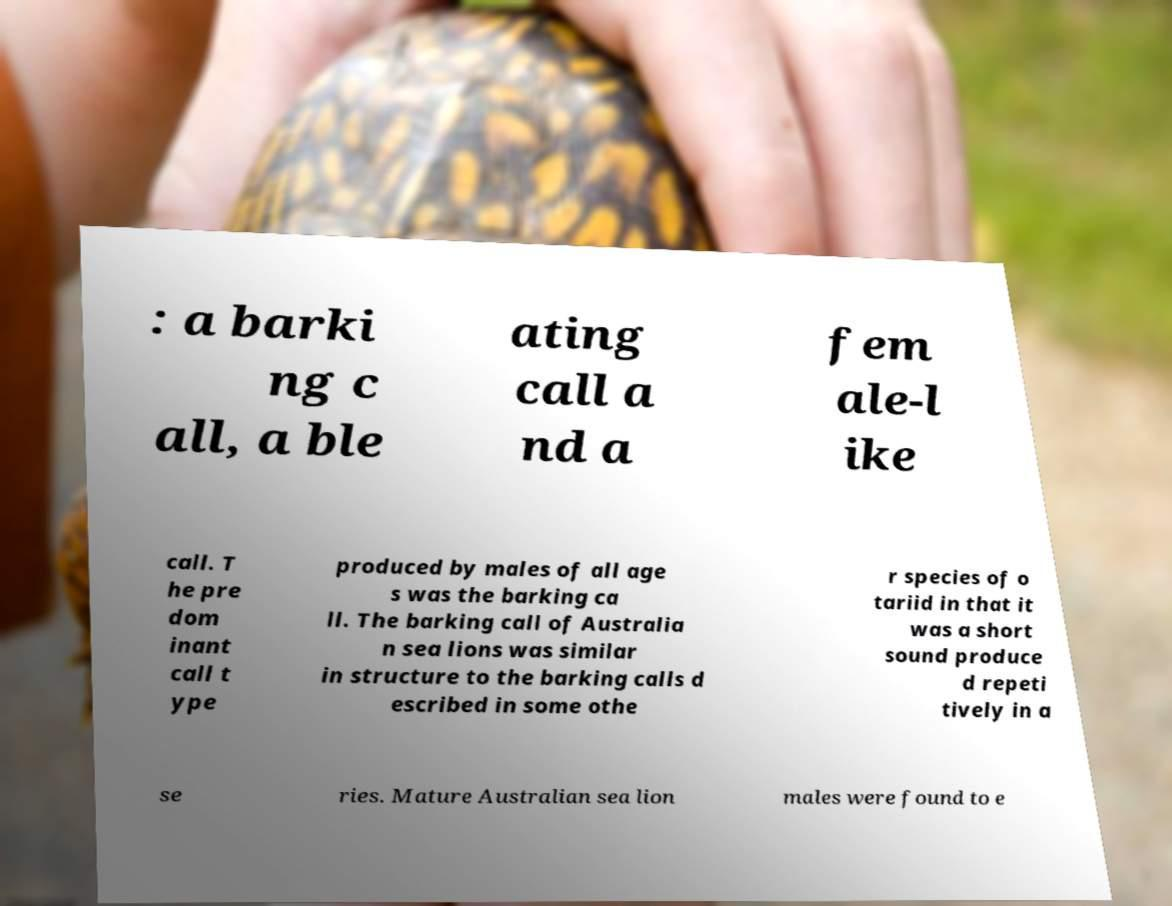Please identify and transcribe the text found in this image. : a barki ng c all, a ble ating call a nd a fem ale-l ike call. T he pre dom inant call t ype produced by males of all age s was the barking ca ll. The barking call of Australia n sea lions was similar in structure to the barking calls d escribed in some othe r species of o tariid in that it was a short sound produce d repeti tively in a se ries. Mature Australian sea lion males were found to e 